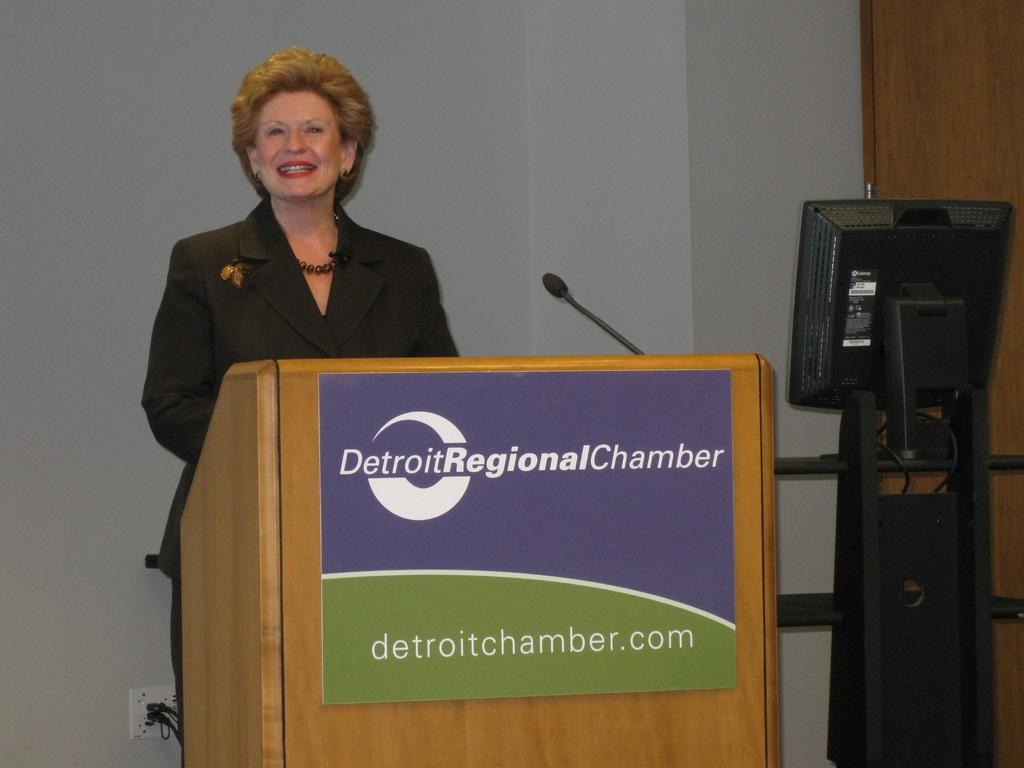What is the main subject of the image? There is a woman standing in the image. What object can be seen on the right side of the image? There is a computer on the right side of the image. What type of disease is the woman suffering from in the image? There is no indication of any disease in the image; it only shows a woman standing and a computer on the right side. 